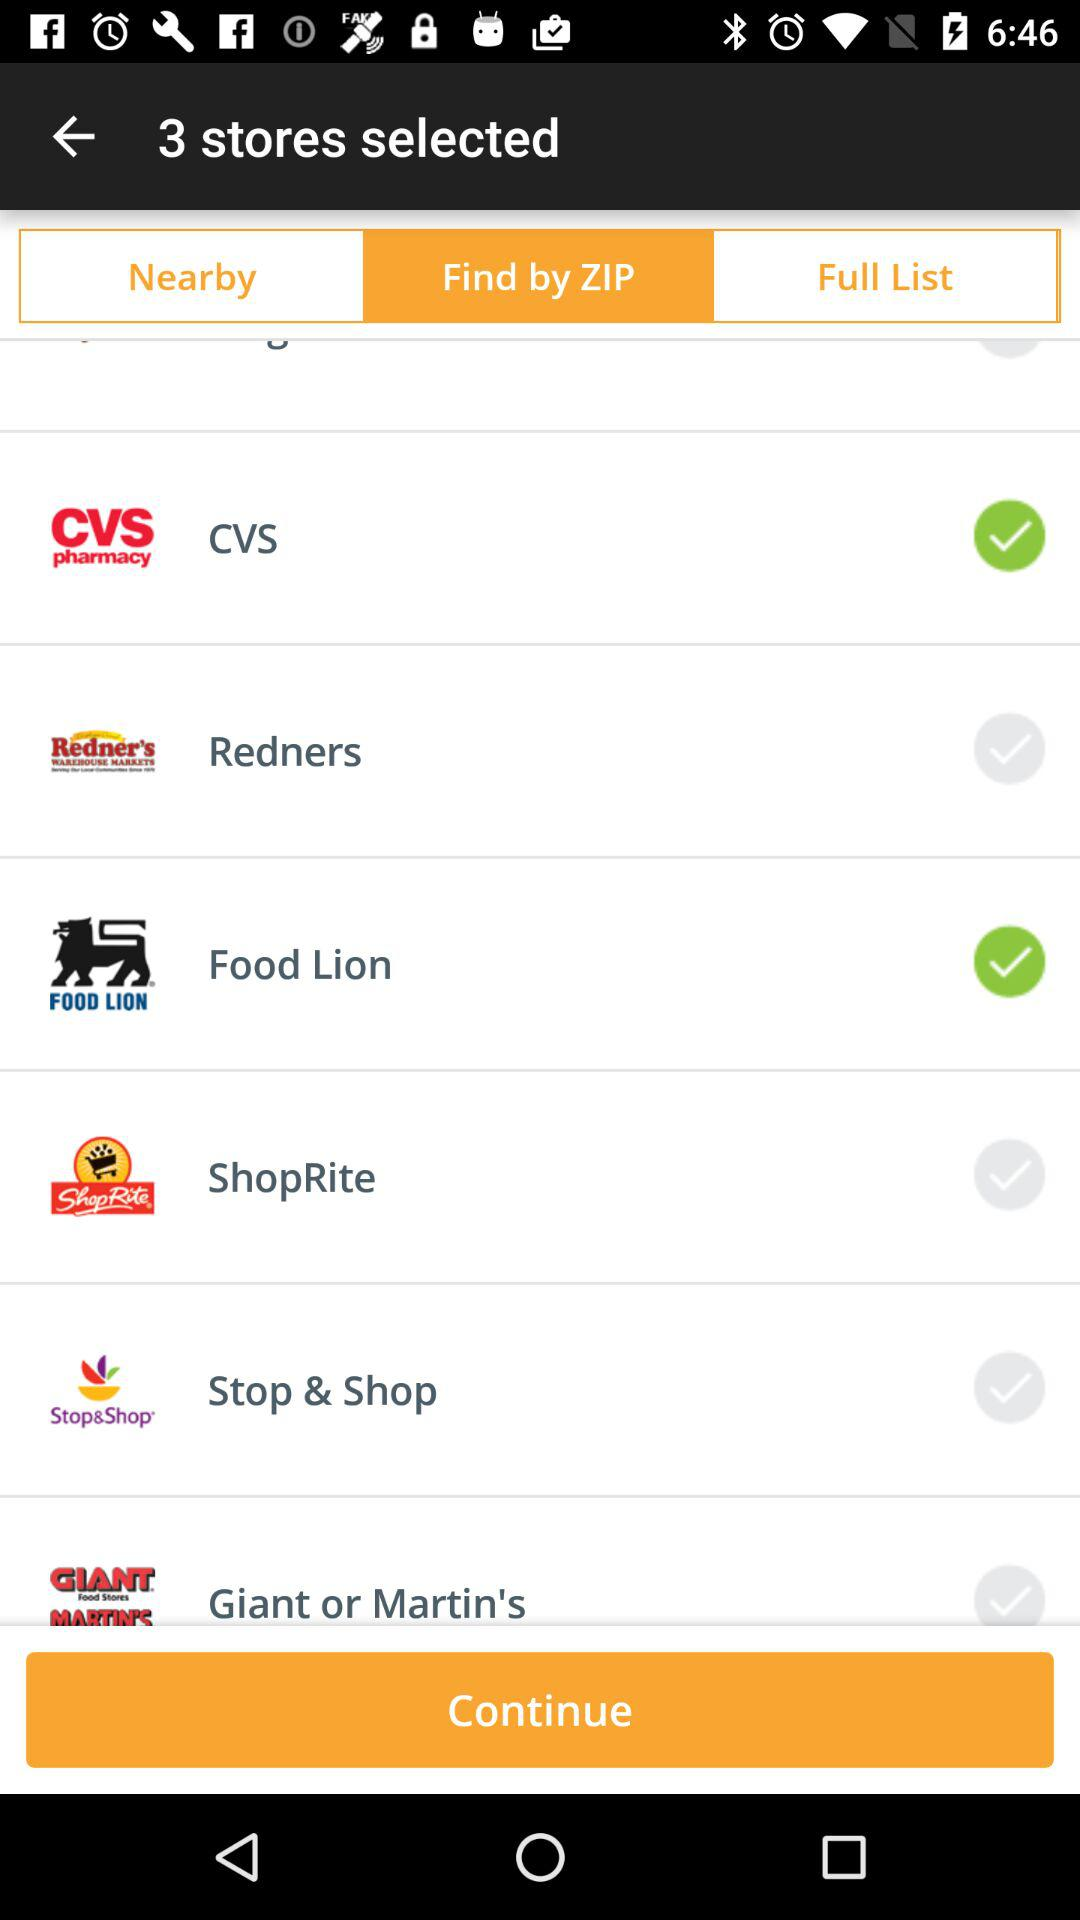Which tab has been selected? The tab that has been selected is "Find by ZIP". 